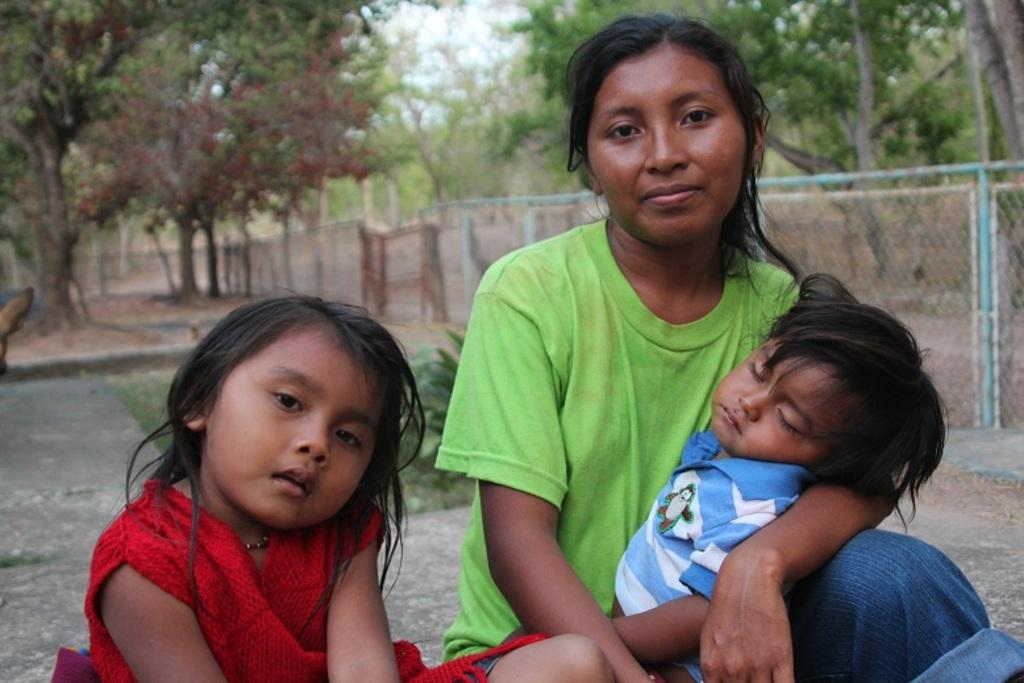Who is present in the image? There is a woman and two children in the image. What are they doing in the image? The woman and children are sitting on a path. What can be seen in the background of the image? There are trees, plants, and a net fence behind them. What type of poison is being used by the children in the image? There is no poison present in the image; the children are simply sitting on a path with the woman. 